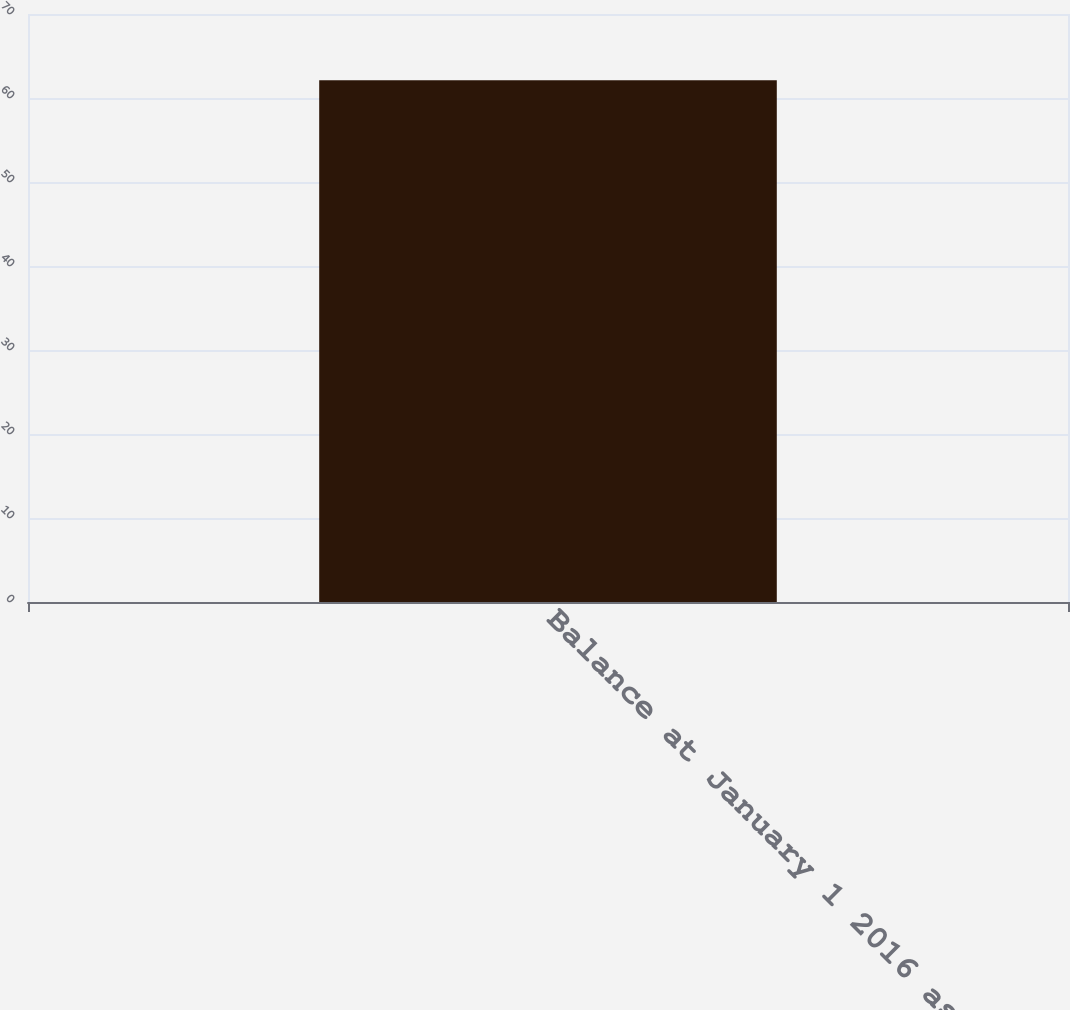<chart> <loc_0><loc_0><loc_500><loc_500><bar_chart><fcel>Balance at January 1 2016 as<nl><fcel>62.1<nl></chart> 